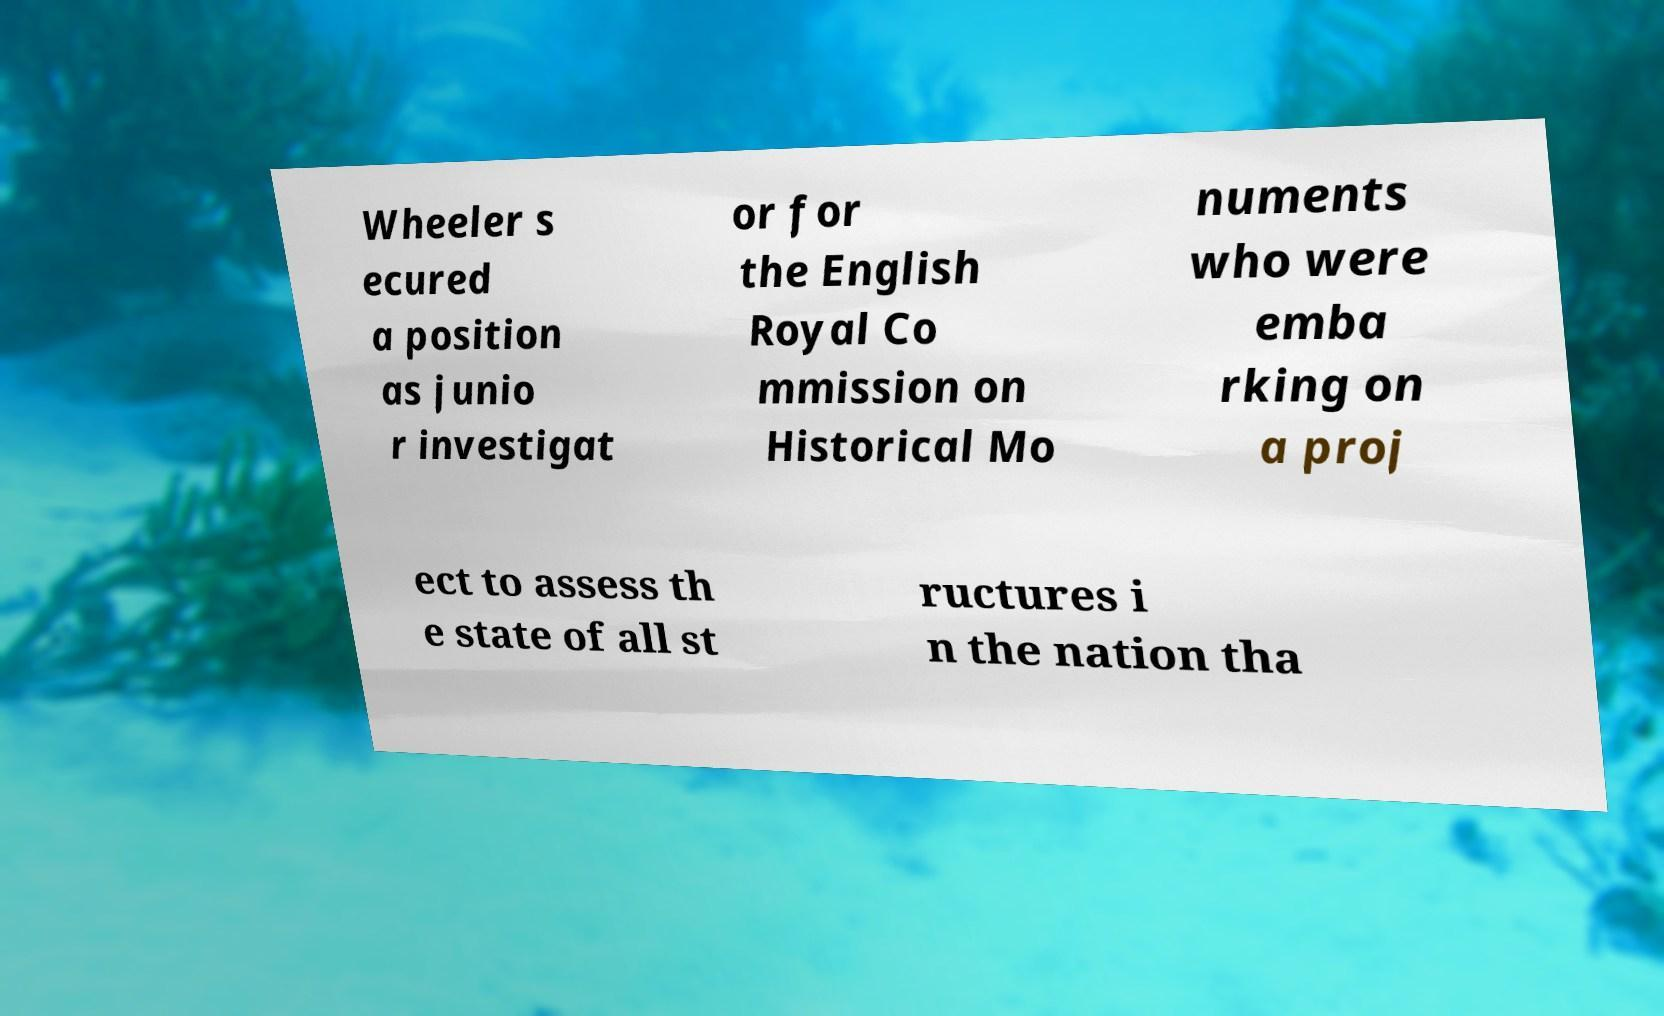Please read and relay the text visible in this image. What does it say? Wheeler s ecured a position as junio r investigat or for the English Royal Co mmission on Historical Mo numents who were emba rking on a proj ect to assess th e state of all st ructures i n the nation tha 